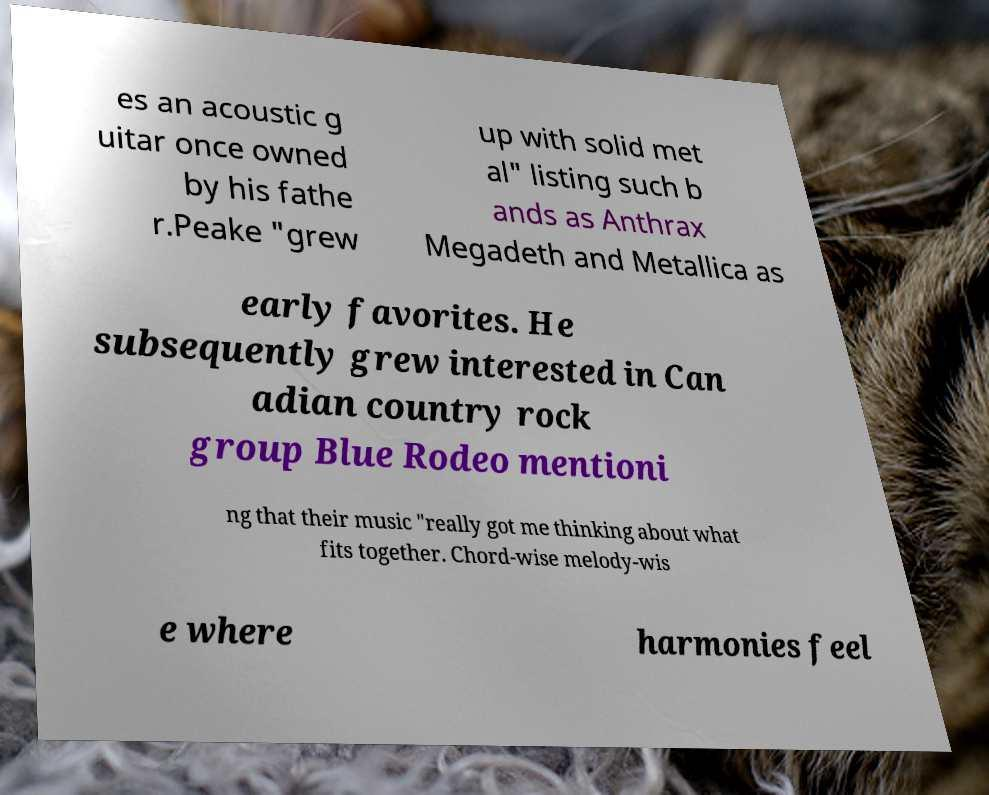What messages or text are displayed in this image? I need them in a readable, typed format. es an acoustic g uitar once owned by his fathe r.Peake "grew up with solid met al" listing such b ands as Anthrax Megadeth and Metallica as early favorites. He subsequently grew interested in Can adian country rock group Blue Rodeo mentioni ng that their music "really got me thinking about what fits together. Chord-wise melody-wis e where harmonies feel 